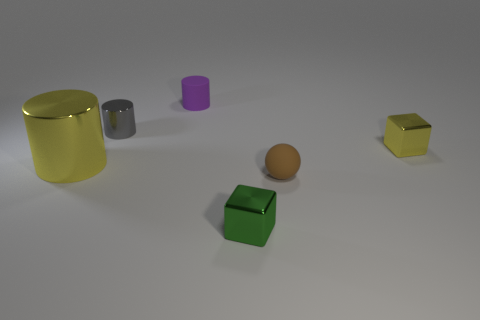How do the sizes of the objects compare to each other? The sizes of the objects vary. The yellow cylinder is the largest, followed by the green cube which is comparable in size to the yellow cube. The spherical object is smaller, and the purple and grey cylinders are smaller still, possibly due to their position further back in the scene which could affect our perspective on their size. 